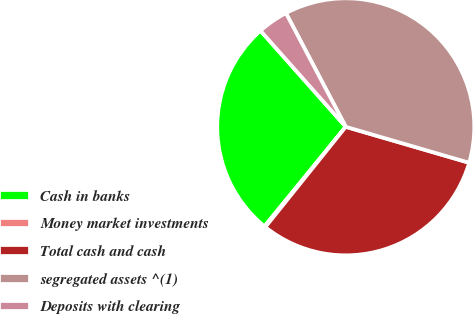Convert chart. <chart><loc_0><loc_0><loc_500><loc_500><pie_chart><fcel>Cash in banks<fcel>Money market investments<fcel>Total cash and cash<fcel>segregated assets ^(1)<fcel>Deposits with clearing<nl><fcel>27.55%<fcel>0.14%<fcel>31.25%<fcel>37.22%<fcel>3.84%<nl></chart> 